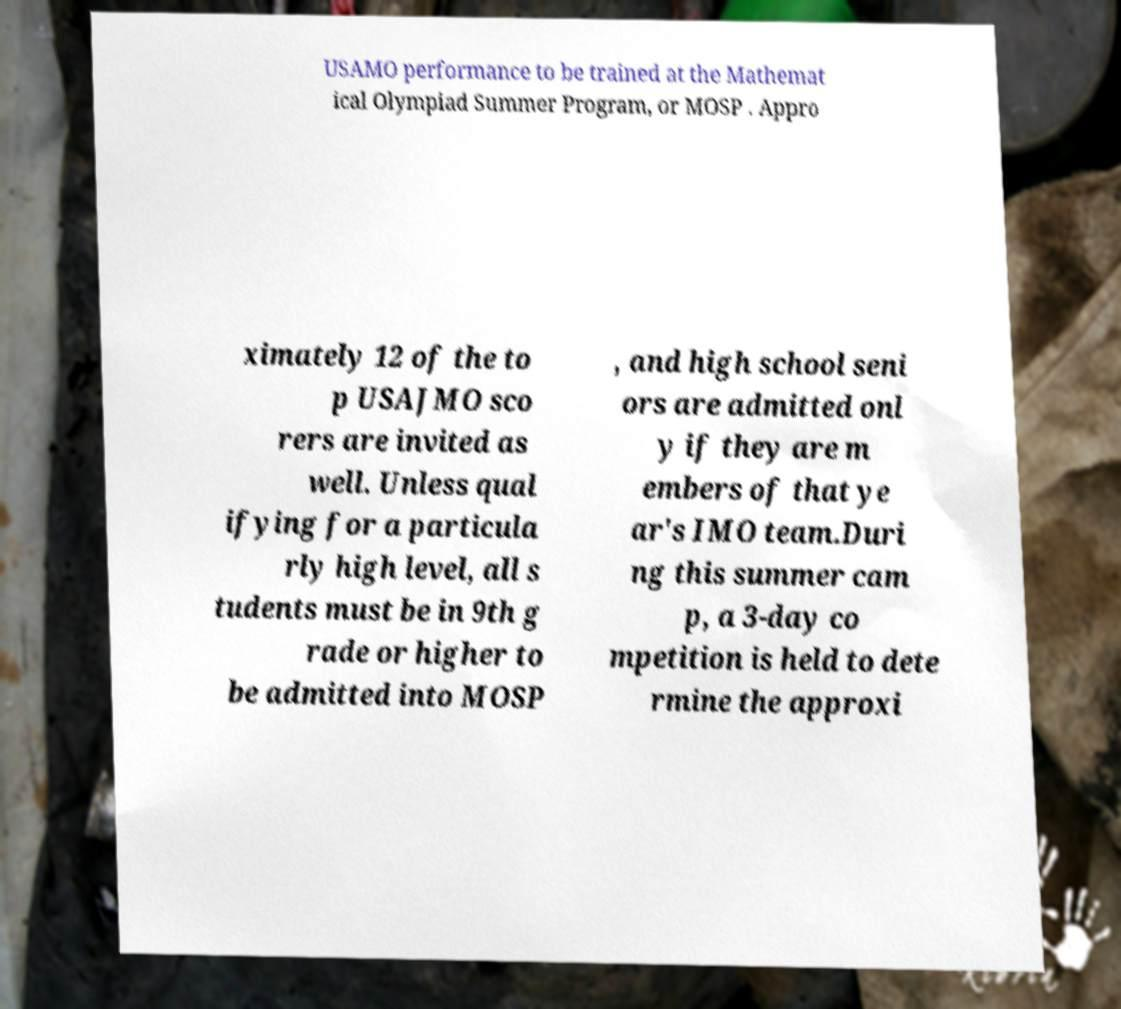I need the written content from this picture converted into text. Can you do that? USAMO performance to be trained at the Mathemat ical Olympiad Summer Program, or MOSP . Appro ximately 12 of the to p USAJMO sco rers are invited as well. Unless qual ifying for a particula rly high level, all s tudents must be in 9th g rade or higher to be admitted into MOSP , and high school seni ors are admitted onl y if they are m embers of that ye ar's IMO team.Duri ng this summer cam p, a 3-day co mpetition is held to dete rmine the approxi 